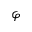Convert formula to latex. <formula><loc_0><loc_0><loc_500><loc_500>\varphi</formula> 